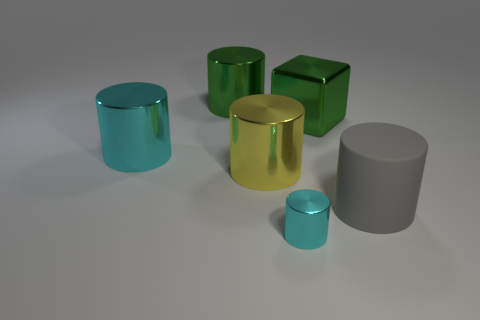What is the color of the tiny cylinder that is made of the same material as the cube? cyan 